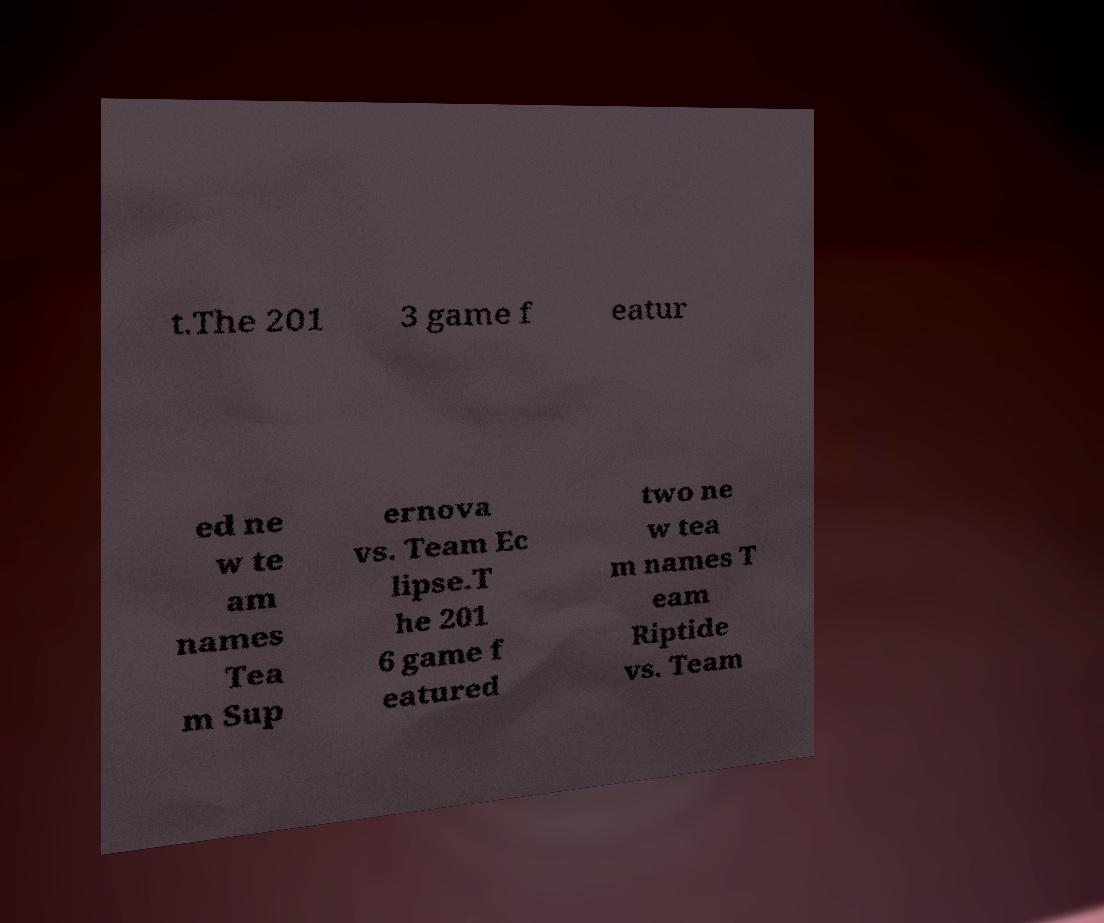Could you assist in decoding the text presented in this image and type it out clearly? t.The 201 3 game f eatur ed ne w te am names Tea m Sup ernova vs. Team Ec lipse.T he 201 6 game f eatured two ne w tea m names T eam Riptide vs. Team 